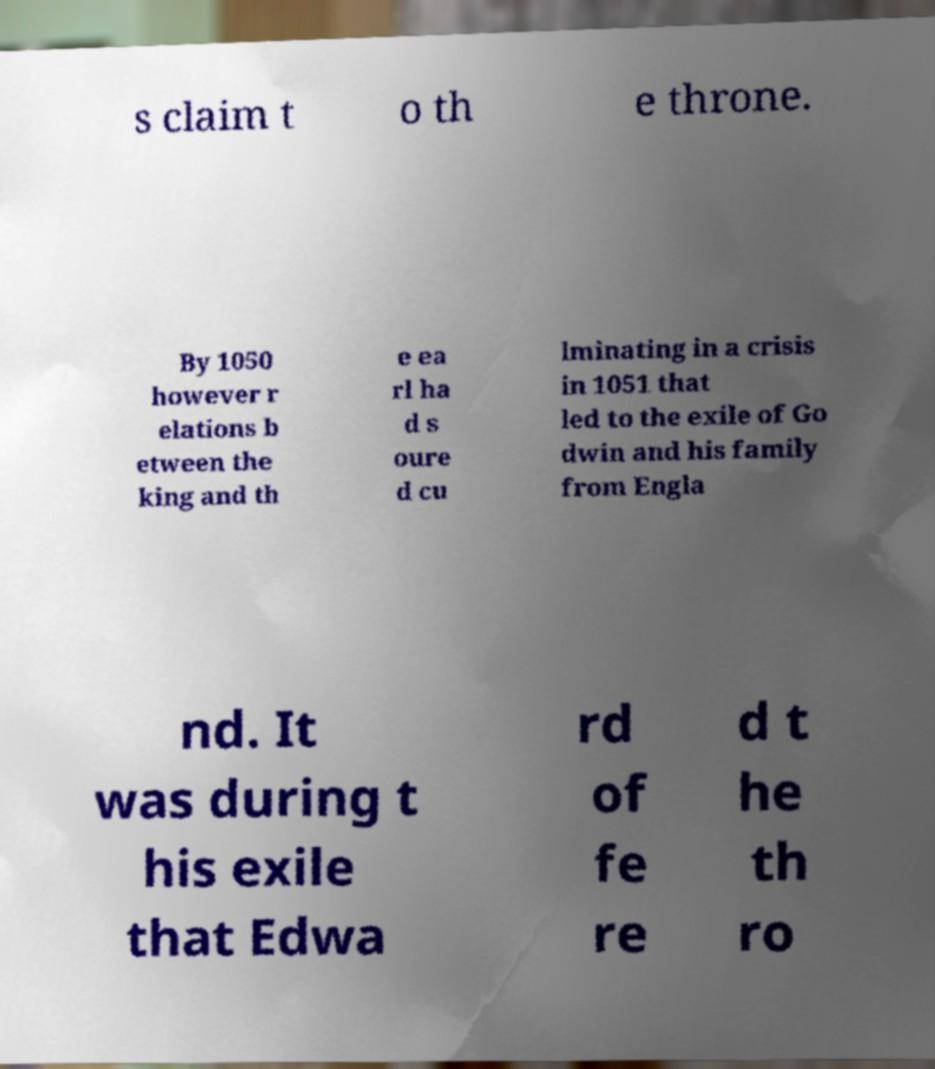What messages or text are displayed in this image? I need them in a readable, typed format. s claim t o th e throne. By 1050 however r elations b etween the king and th e ea rl ha d s oure d cu lminating in a crisis in 1051 that led to the exile of Go dwin and his family from Engla nd. It was during t his exile that Edwa rd of fe re d t he th ro 